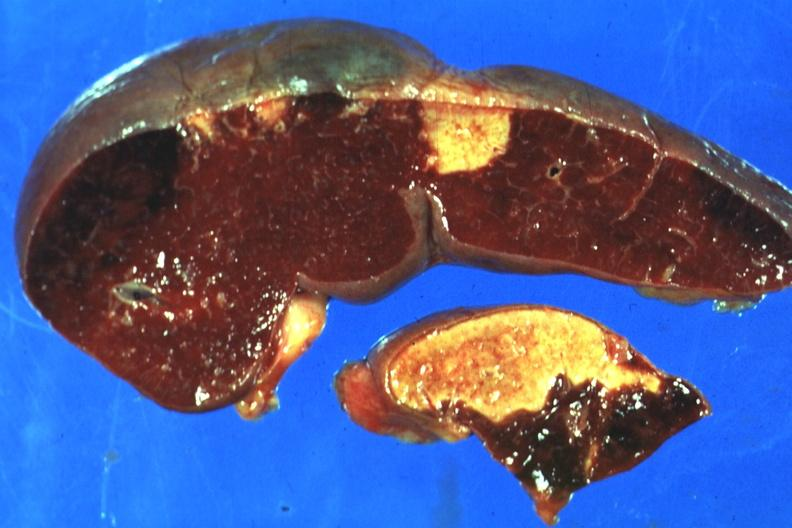what is present?
Answer the question using a single word or phrase. Spleen 